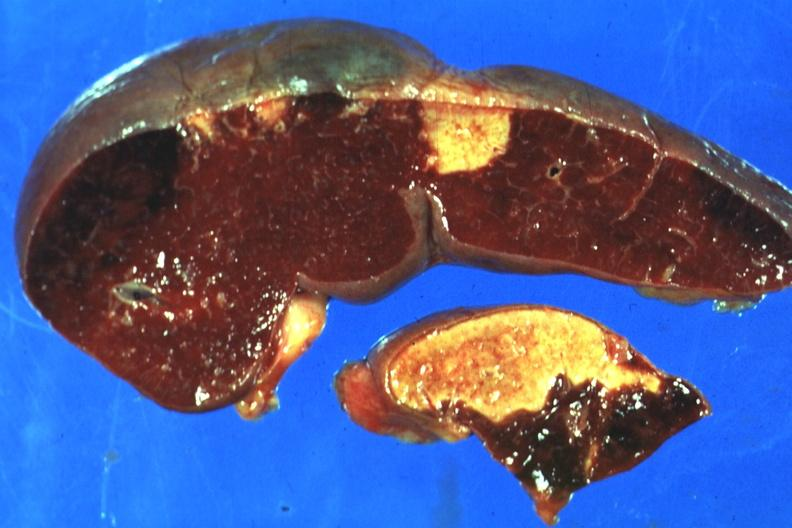what is present?
Answer the question using a single word or phrase. Spleen 